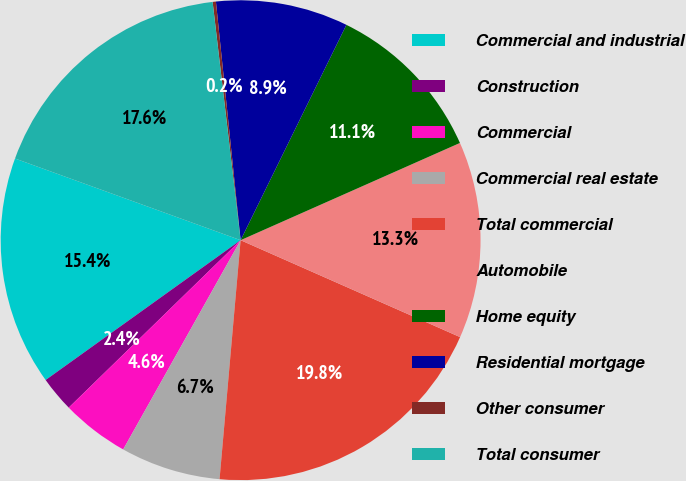Convert chart. <chart><loc_0><loc_0><loc_500><loc_500><pie_chart><fcel>Commercial and industrial<fcel>Construction<fcel>Commercial<fcel>Commercial real estate<fcel>Total commercial<fcel>Automobile<fcel>Home equity<fcel>Residential mortgage<fcel>Other consumer<fcel>Total consumer<nl><fcel>15.43%<fcel>2.39%<fcel>4.57%<fcel>6.74%<fcel>19.78%<fcel>13.26%<fcel>11.09%<fcel>8.91%<fcel>0.22%<fcel>17.61%<nl></chart> 